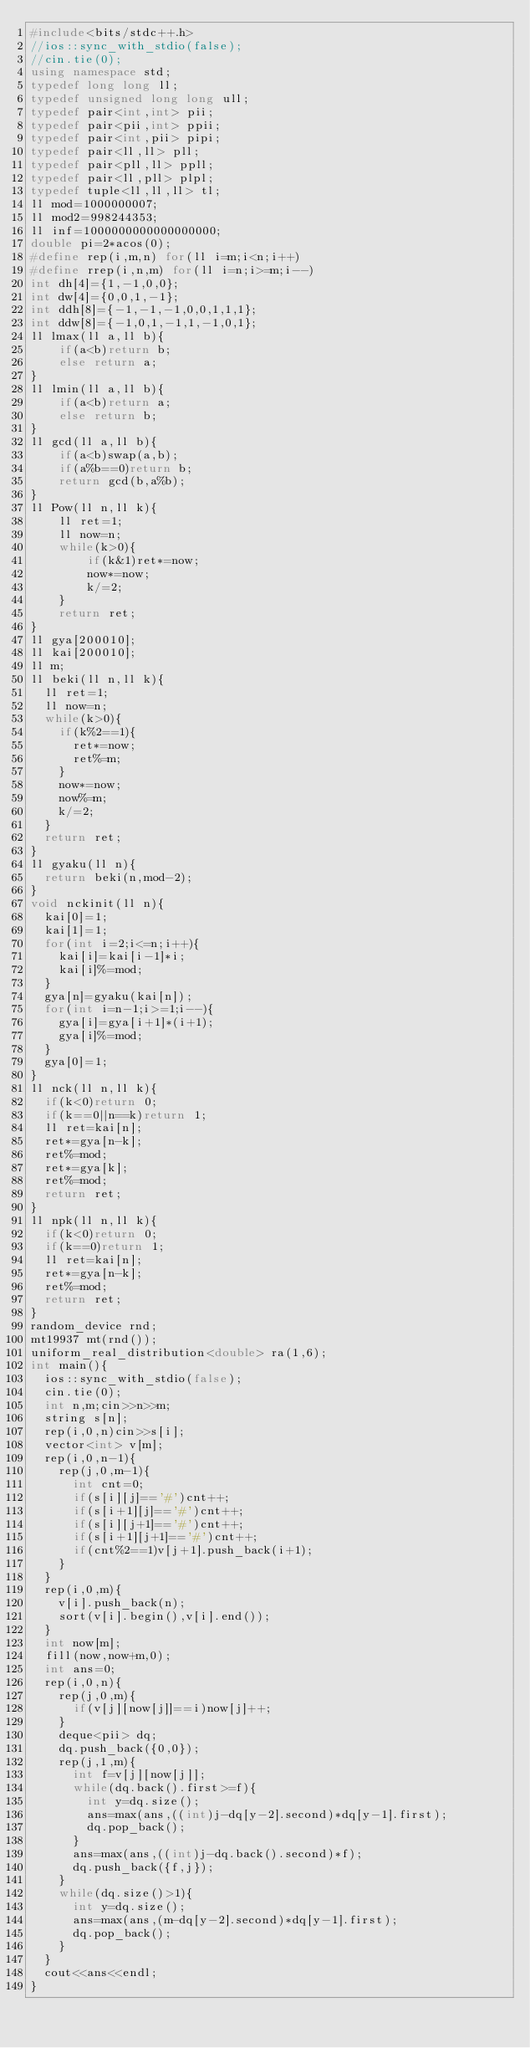<code> <loc_0><loc_0><loc_500><loc_500><_C++_>#include<bits/stdc++.h>
//ios::sync_with_stdio(false);
//cin.tie(0);
using namespace std;
typedef long long ll;
typedef unsigned long long ull;
typedef pair<int,int> pii;
typedef pair<pii,int> ppii;
typedef pair<int,pii> pipi;
typedef pair<ll,ll> pll;
typedef pair<pll,ll> ppll;
typedef pair<ll,pll> plpl;
typedef tuple<ll,ll,ll> tl;
ll mod=1000000007;
ll mod2=998244353;
ll inf=1000000000000000000;
double pi=2*acos(0);
#define rep(i,m,n) for(ll i=m;i<n;i++)
#define rrep(i,n,m) for(ll i=n;i>=m;i--)
int dh[4]={1,-1,0,0};
int dw[4]={0,0,1,-1};
int ddh[8]={-1,-1,-1,0,0,1,1,1};
int ddw[8]={-1,0,1,-1,1,-1,0,1};
ll lmax(ll a,ll b){
    if(a<b)return b;
    else return a;
}
ll lmin(ll a,ll b){
    if(a<b)return a;
    else return b;
}
ll gcd(ll a,ll b){
    if(a<b)swap(a,b);
    if(a%b==0)return b;
    return gcd(b,a%b);
}
ll Pow(ll n,ll k){
    ll ret=1;
    ll now=n;
    while(k>0){
        if(k&1)ret*=now;
        now*=now;
        k/=2;
    }
    return ret;
}
ll gya[200010];
ll kai[200010];
ll m;
ll beki(ll n,ll k){
  ll ret=1;
  ll now=n;
  while(k>0){
    if(k%2==1){
      ret*=now;
      ret%=m;
    }
    now*=now;
    now%=m;
    k/=2;
  }
  return ret;
}
ll gyaku(ll n){
  return beki(n,mod-2);
}
void nckinit(ll n){
  kai[0]=1;
  kai[1]=1;
  for(int i=2;i<=n;i++){
    kai[i]=kai[i-1]*i;
    kai[i]%=mod;
  }
  gya[n]=gyaku(kai[n]);
  for(int i=n-1;i>=1;i--){
    gya[i]=gya[i+1]*(i+1);
    gya[i]%=mod;
  }
  gya[0]=1;
}    
ll nck(ll n,ll k){
  if(k<0)return 0;
  if(k==0||n==k)return 1;
  ll ret=kai[n];
  ret*=gya[n-k];
  ret%=mod;
  ret*=gya[k];
  ret%=mod;
  return ret;
}
ll npk(ll n,ll k){
  if(k<0)return 0;
  if(k==0)return 1;
  ll ret=kai[n];
  ret*=gya[n-k];
  ret%=mod;
  return ret;
}
random_device rnd;
mt19937 mt(rnd());
uniform_real_distribution<double> ra(1,6);
int main(){
  ios::sync_with_stdio(false);
  cin.tie(0);
  int n,m;cin>>n>>m;
  string s[n];
  rep(i,0,n)cin>>s[i];
  vector<int> v[m];
  rep(i,0,n-1){
    rep(j,0,m-1){
      int cnt=0;
      if(s[i][j]=='#')cnt++;
      if(s[i+1][j]=='#')cnt++;
      if(s[i][j+1]=='#')cnt++;
      if(s[i+1][j+1]=='#')cnt++;
      if(cnt%2==1)v[j+1].push_back(i+1);
    }
  }
  rep(i,0,m){
    v[i].push_back(n);
    sort(v[i].begin(),v[i].end());
  }
  int now[m];
  fill(now,now+m,0);
  int ans=0;
  rep(i,0,n){
    rep(j,0,m){
      if(v[j][now[j]]==i)now[j]++;
    }
    deque<pii> dq;
    dq.push_back({0,0});
    rep(j,1,m){
      int f=v[j][now[j]];
      while(dq.back().first>=f){
        int y=dq.size();
        ans=max(ans,((int)j-dq[y-2].second)*dq[y-1].first);
        dq.pop_back();
      }
      ans=max(ans,((int)j-dq.back().second)*f);
      dq.push_back({f,j});
    }
    while(dq.size()>1){
      int y=dq.size();
      ans=max(ans,(m-dq[y-2].second)*dq[y-1].first);
      dq.pop_back();
    }
  }
  cout<<ans<<endl;
}</code> 